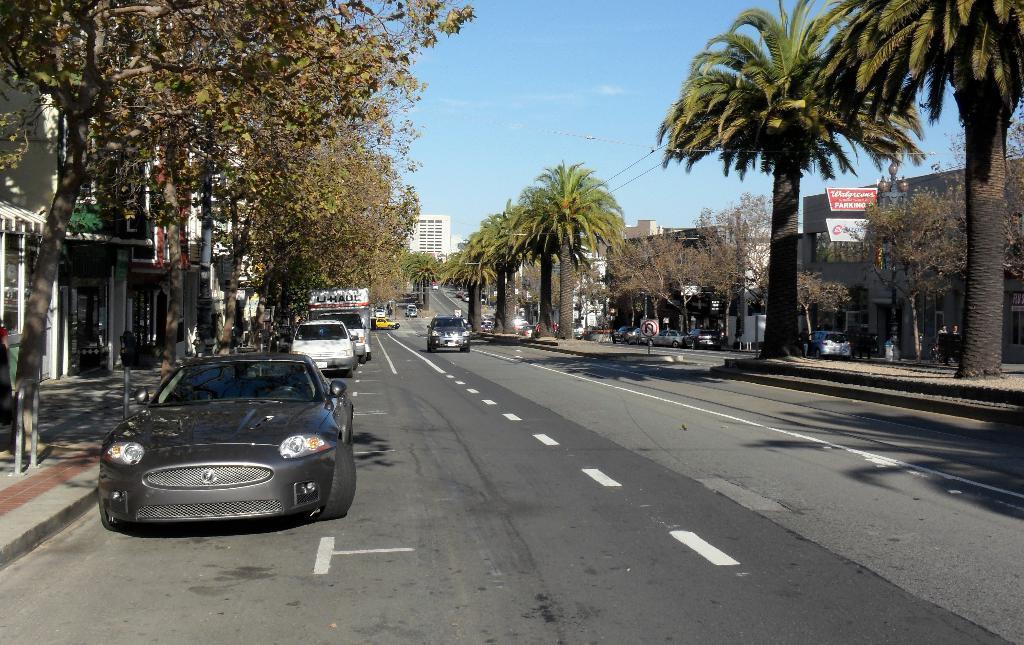Can you describe this image briefly? This is the picture of a city. In this image there are vehicles on the road. On the left and on the right side of the image there are trees and buildings. At the top there is sky. At the bottom there is a road. On the right side of the image there are two persons walking on the footpath. 